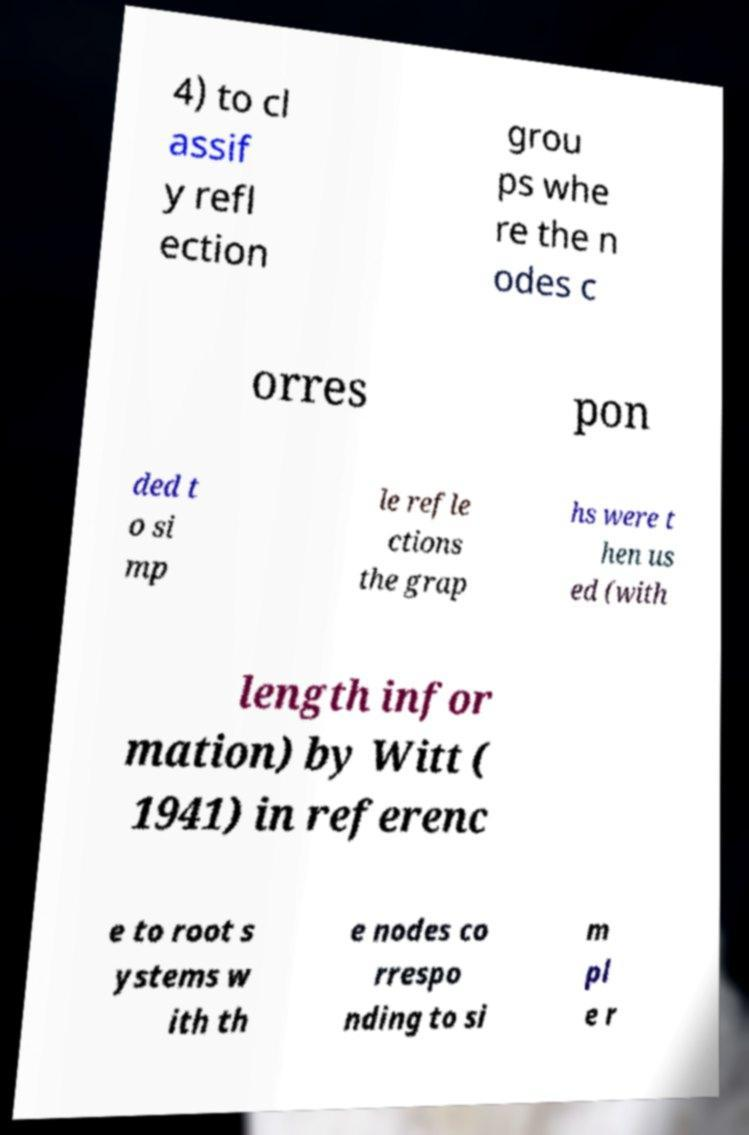Could you extract and type out the text from this image? 4) to cl assif y refl ection grou ps whe re the n odes c orres pon ded t o si mp le refle ctions the grap hs were t hen us ed (with length infor mation) by Witt ( 1941) in referenc e to root s ystems w ith th e nodes co rrespo nding to si m pl e r 